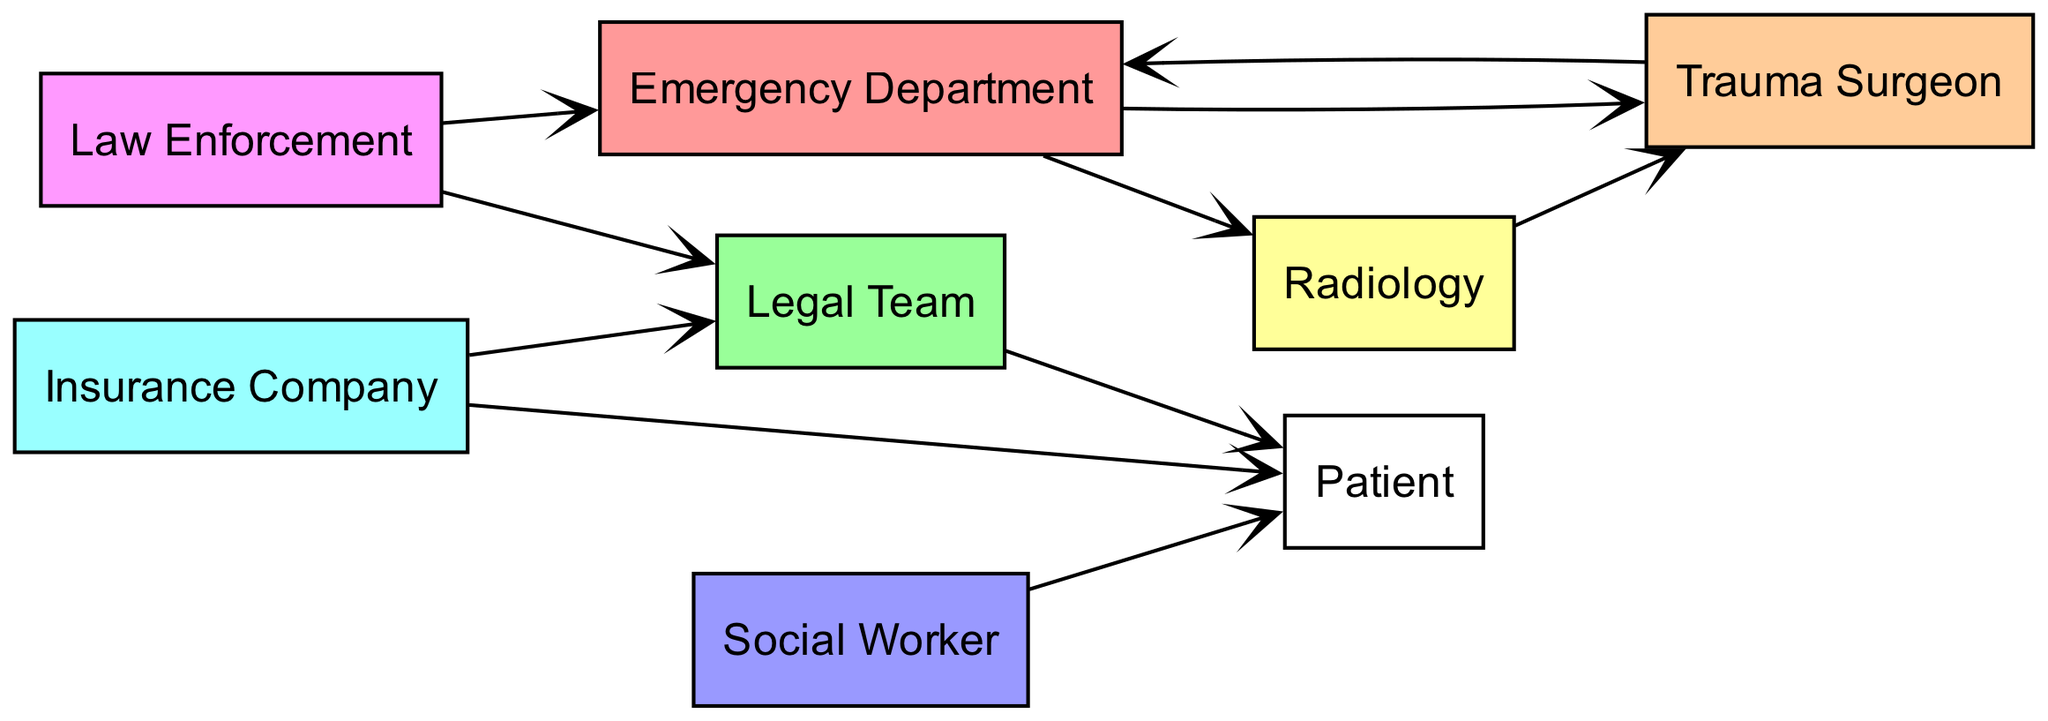What is the total number of nodes in the diagram? The nodes listed are: Emergency Department, Trauma Surgeon, Radiology, Legal Team, Insurance Company, Social Worker, Law Enforcement, and Patient, which gives a total of eight nodes.
Answer: 8 Which department interacts with both the Trauma Surgeon and Radiology? The diagram shows an interaction arrow from Radiology to Trauma Surgeon, indicating that the Radiology department sends information or results to the Trauma Surgeon.
Answer: Radiology How many edges are present in the diagram? By counting the connections (arrows) between the nodes listed in the edges section of the data, there are ten edges in total.
Answer: 10 Which node has a direct interaction with Law Enforcement? The edges indicate that Law Enforcement interacts directly with both the Emergency Department and the Legal Team, as there are arrows pointing to these nodes from Law Enforcement.
Answer: Emergency Department and Legal Team What is the relationship between the Insurance Company and the Patient? The Insurance Company has a direct arrow leading to the Patient, indicating that the Insurance Company is involved with or impacting the Patient's care directly.
Answer: Interaction Which node does the Social Worker interact with? The edge information shows that the Social Worker interacts directly with the Patient, indicated by an arrow pointing from Social Worker to Patient.
Answer: Patient Which node(s) does the Emergency Department connect to? The Emergency Department has arrows pointing to both the Trauma Surgeon and Radiology, illustrating that it interacts with both of these departments directly.
Answer: Trauma Surgeon and Radiology What type of external agency interacts with both the Emergency Department and the Legal Team? The Law Enforcement node has arrows pointing to both the Emergency Department and the Legal Team, indicating its direct interaction with both.
Answer: Law Enforcement How many nodes are directly connected to the Patient? The Patient is directly connected to the Legal Team, Insurance Company, and Social Worker, which totals three nodes interacting with the Patient.
Answer: 3 